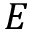Convert formula to latex. <formula><loc_0><loc_0><loc_500><loc_500>E</formula> 